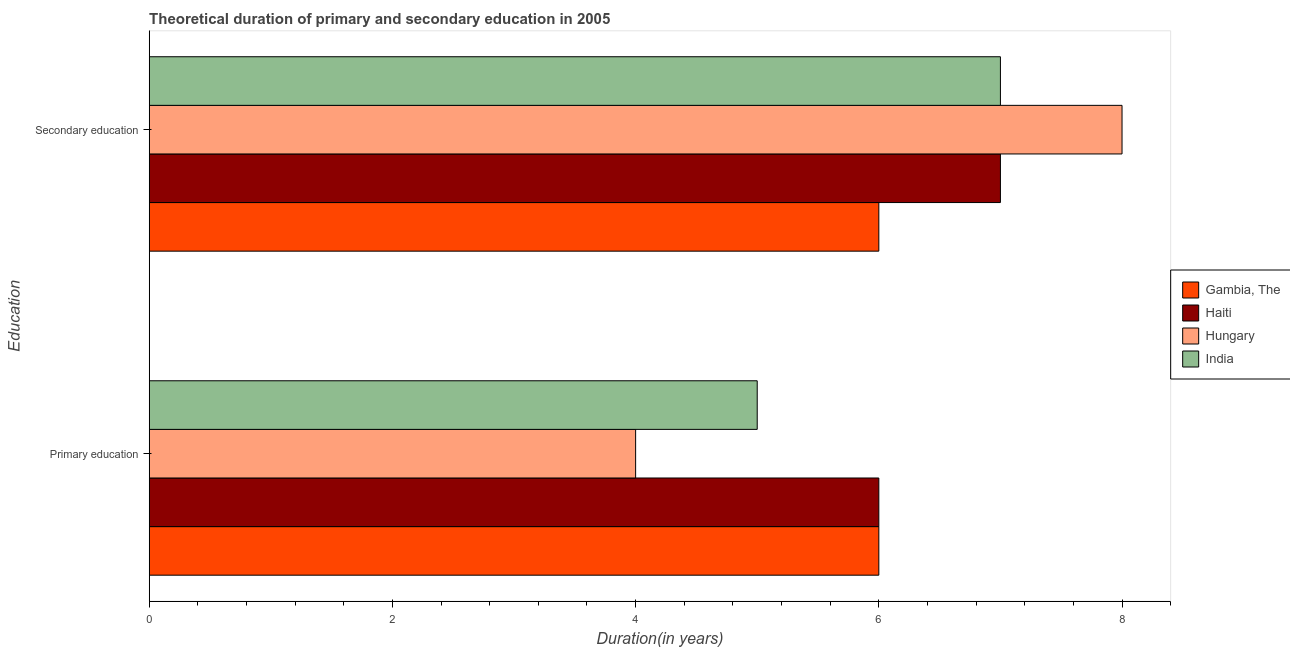How many different coloured bars are there?
Provide a succinct answer. 4. How many groups of bars are there?
Give a very brief answer. 2. Are the number of bars on each tick of the Y-axis equal?
Offer a terse response. Yes. What is the label of the 2nd group of bars from the top?
Offer a very short reply. Primary education. Across all countries, what is the maximum duration of secondary education?
Offer a very short reply. 8. In which country was the duration of secondary education maximum?
Ensure brevity in your answer.  Hungary. In which country was the duration of primary education minimum?
Give a very brief answer. Hungary. What is the total duration of secondary education in the graph?
Provide a short and direct response. 28. What is the average duration of primary education per country?
Ensure brevity in your answer.  5.25. What is the difference between the duration of secondary education and duration of primary education in Gambia, The?
Your answer should be very brief. 0. What is the ratio of the duration of primary education in Haiti to that in Hungary?
Make the answer very short. 1.5. In how many countries, is the duration of primary education greater than the average duration of primary education taken over all countries?
Provide a succinct answer. 2. What does the 3rd bar from the top in Secondary education represents?
Your answer should be very brief. Haiti. What does the 3rd bar from the bottom in Primary education represents?
Provide a succinct answer. Hungary. How many countries are there in the graph?
Offer a very short reply. 4. What is the difference between two consecutive major ticks on the X-axis?
Give a very brief answer. 2. Does the graph contain grids?
Provide a short and direct response. No. Where does the legend appear in the graph?
Offer a terse response. Center right. How many legend labels are there?
Keep it short and to the point. 4. How are the legend labels stacked?
Make the answer very short. Vertical. What is the title of the graph?
Make the answer very short. Theoretical duration of primary and secondary education in 2005. What is the label or title of the X-axis?
Make the answer very short. Duration(in years). What is the label or title of the Y-axis?
Keep it short and to the point. Education. What is the Duration(in years) in Hungary in Secondary education?
Offer a very short reply. 8. What is the Duration(in years) of India in Secondary education?
Keep it short and to the point. 7. Across all Education, what is the maximum Duration(in years) in Gambia, The?
Give a very brief answer. 6. Across all Education, what is the minimum Duration(in years) in Gambia, The?
Your response must be concise. 6. Across all Education, what is the minimum Duration(in years) in Haiti?
Offer a terse response. 6. Across all Education, what is the minimum Duration(in years) of India?
Keep it short and to the point. 5. What is the difference between the Duration(in years) in Haiti in Primary education and that in Secondary education?
Your answer should be very brief. -1. What is the difference between the Duration(in years) of Hungary in Primary education and that in Secondary education?
Make the answer very short. -4. What is the difference between the Duration(in years) of India in Primary education and that in Secondary education?
Your answer should be compact. -2. What is the average Duration(in years) in Haiti per Education?
Your answer should be compact. 6.5. What is the average Duration(in years) in Hungary per Education?
Your response must be concise. 6. What is the difference between the Duration(in years) in Gambia, The and Duration(in years) in Haiti in Primary education?
Provide a succinct answer. 0. What is the difference between the Duration(in years) in Gambia, The and Duration(in years) in Hungary in Secondary education?
Your response must be concise. -2. What is the difference between the Duration(in years) in Haiti and Duration(in years) in Hungary in Secondary education?
Make the answer very short. -1. What is the difference between the highest and the second highest Duration(in years) of Gambia, The?
Give a very brief answer. 0. What is the difference between the highest and the second highest Duration(in years) of India?
Give a very brief answer. 2. What is the difference between the highest and the lowest Duration(in years) in India?
Offer a terse response. 2. 